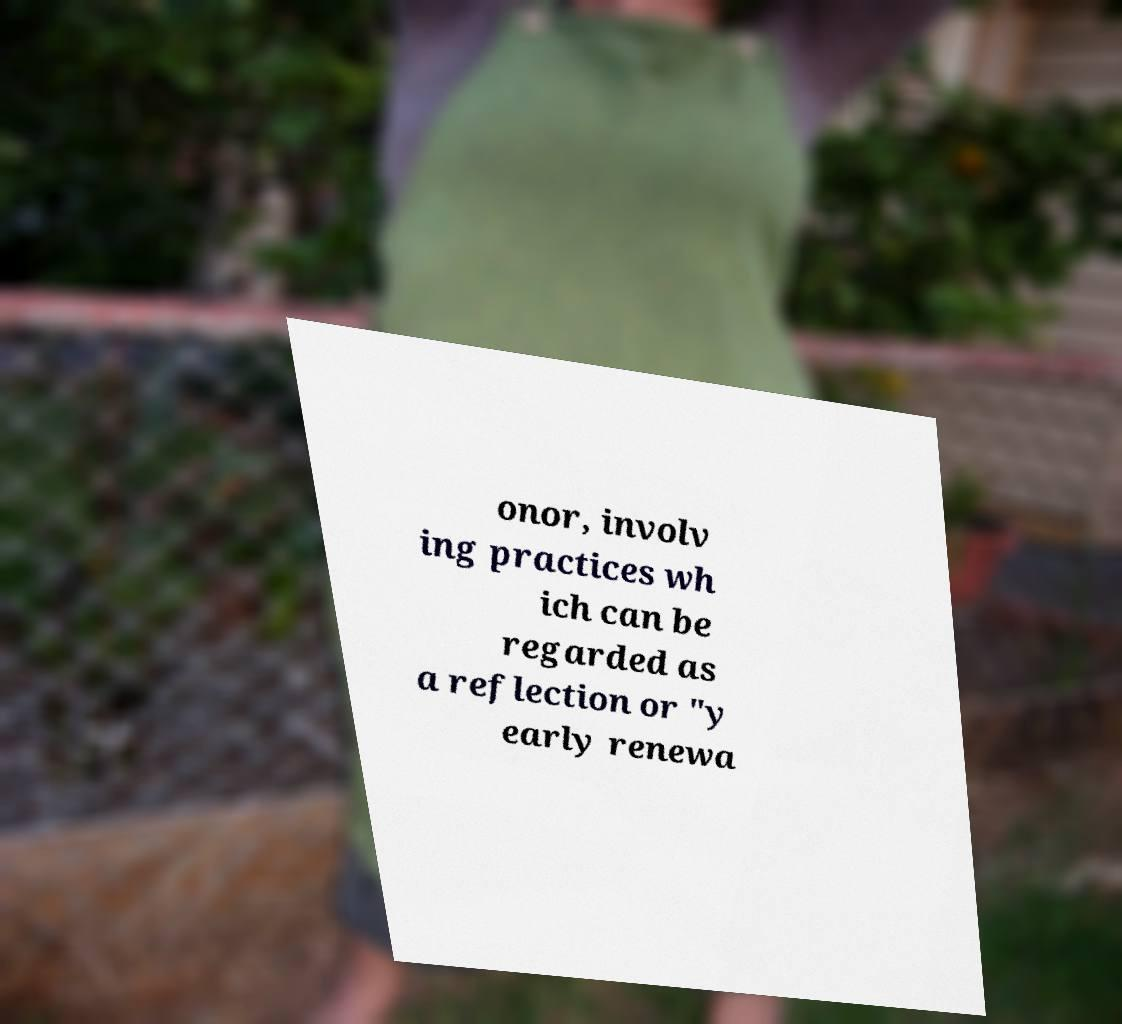Please read and relay the text visible in this image. What does it say? onor, involv ing practices wh ich can be regarded as a reflection or "y early renewa 